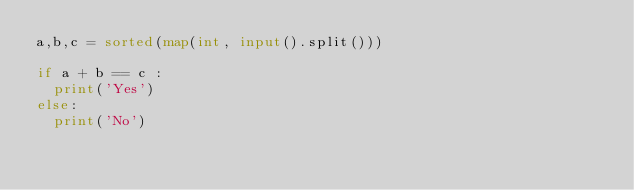Convert code to text. <code><loc_0><loc_0><loc_500><loc_500><_Python_>a,b,c = sorted(map(int, input().split()))

if a + b == c :
	print('Yes')
else:
	print('No')    </code> 